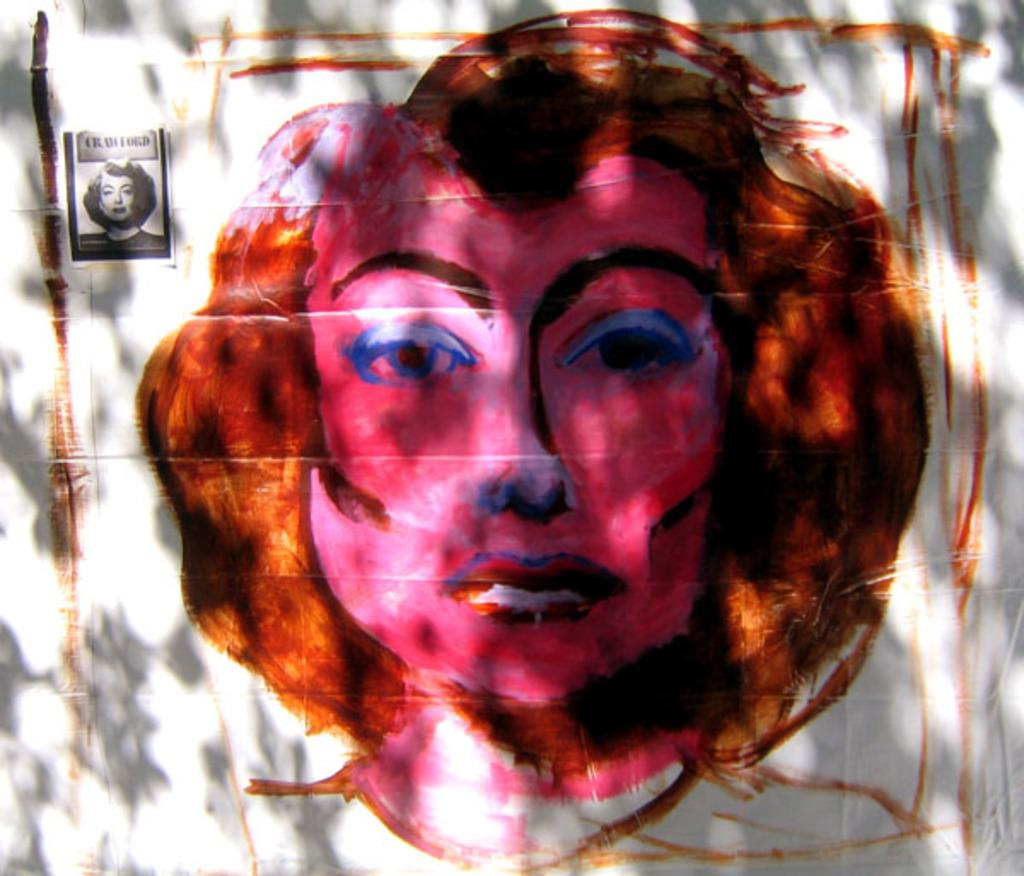What is depicted in the painting in the image? There is a painting of a woman in the image. What else can be seen on the wall in the image? There is a poster on the wall in the image. What type of butter is being used in the meal depicted in the image? There is no meal or butter present in the image; it only features a painting of a woman and a poster on the wall. 